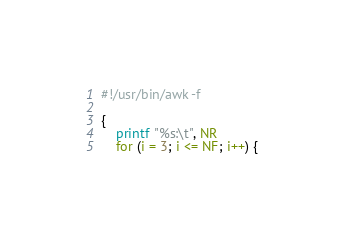<code> <loc_0><loc_0><loc_500><loc_500><_Awk_>#!/usr/bin/awk -f

{
    printf "%s:\t", NR
    for (i = 3; i <= NF; i++) {</code> 